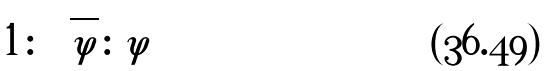<formula> <loc_0><loc_0><loc_500><loc_500>1 \colon \sqrt { \varphi } \colon \varphi</formula> 